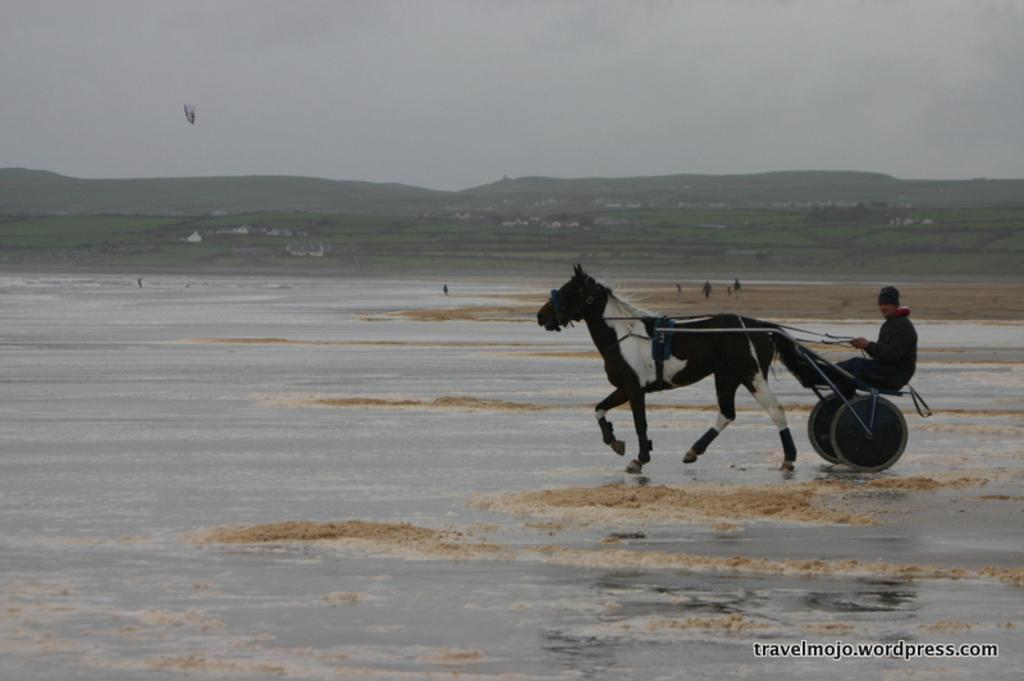What is the man doing in the image? The man is riding a horse cart on the water surface. What can be seen in the background of the image? There are hills, trees, buildings, and the sky visible in the background of the image. Are there any other people in the image besides the man on the horse cart? Yes, there are people on the ground in the image. Where is the nearest airport to the location depicted in the image? The provided facts do not mention an airport, so it is not possible to determine the nearest airport to the location depicted in the image. Can you tell me how many horses are involved in the birth depicted in the image? There is no birth depicted in the image, and therefore no horses are involved in any such event. 